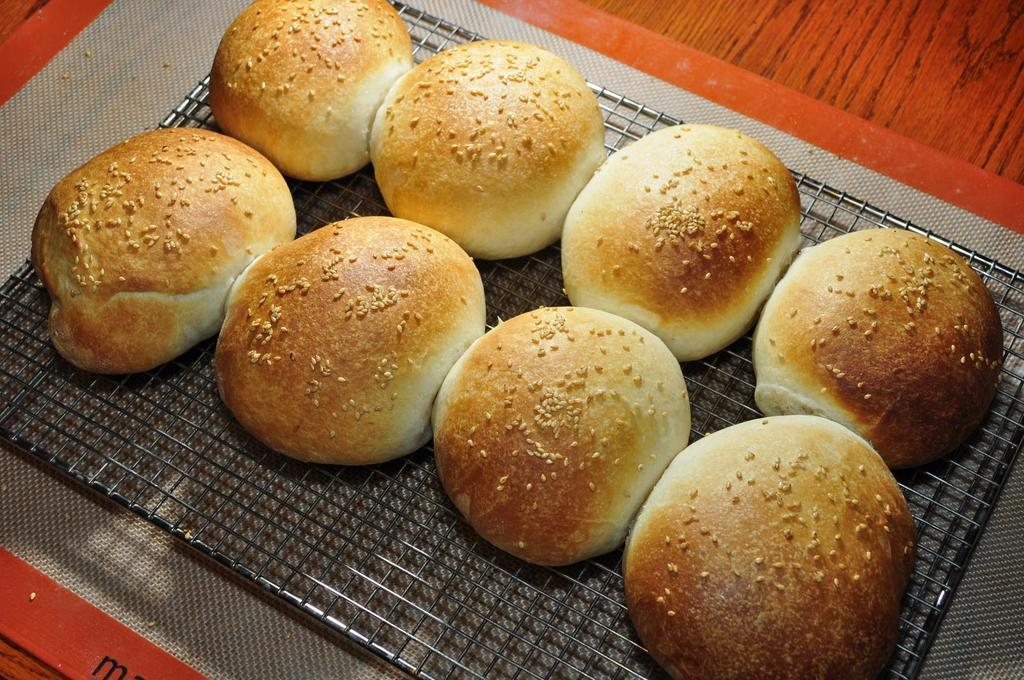What is being cooked on the grill in the image? There are buns on a grill in the image. Where is the grill located in the image? The grill is on a table in the image. Can you see a goose attempting to eat the buns on the grill in the image? No, there is no goose or any other animal present in the image. 